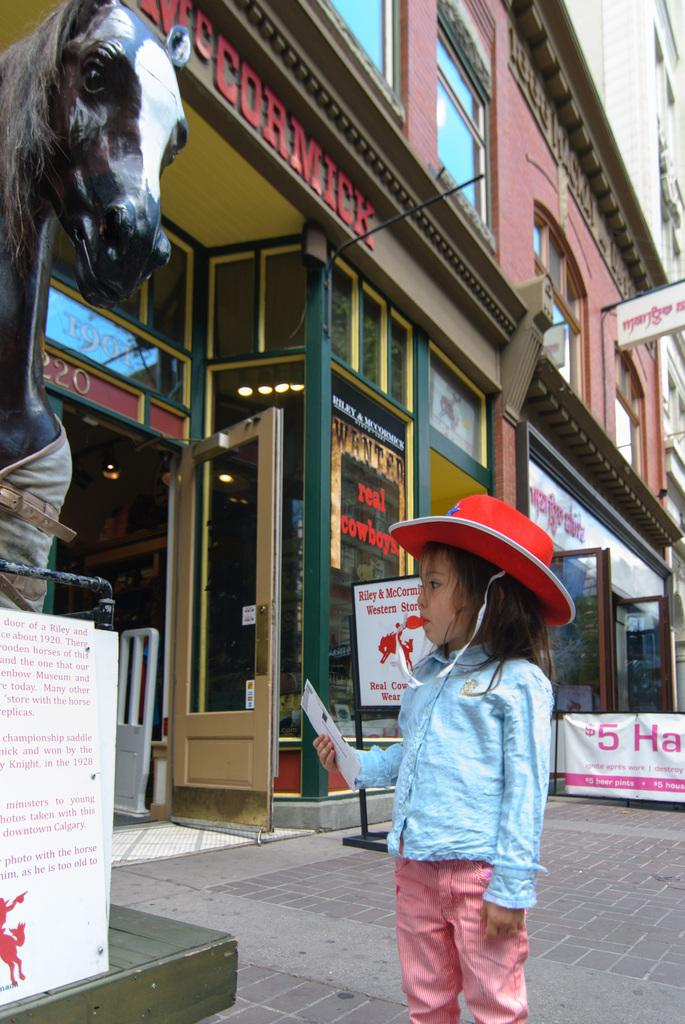Who is the main subject in the image? There is a little girl in the image. What is the girl doing in the image? The girl is standing and observing a statue of a horse. What is the girl wearing on her head? The girl is wearing a red color hat. What can be seen in the background of the image? There is a building in the image. What type of attraction can be seen in the image? There is no attraction present in the image; it features a little girl observing a statue of a horse. How many oranges are visible in the image? There are no oranges present in the image. 